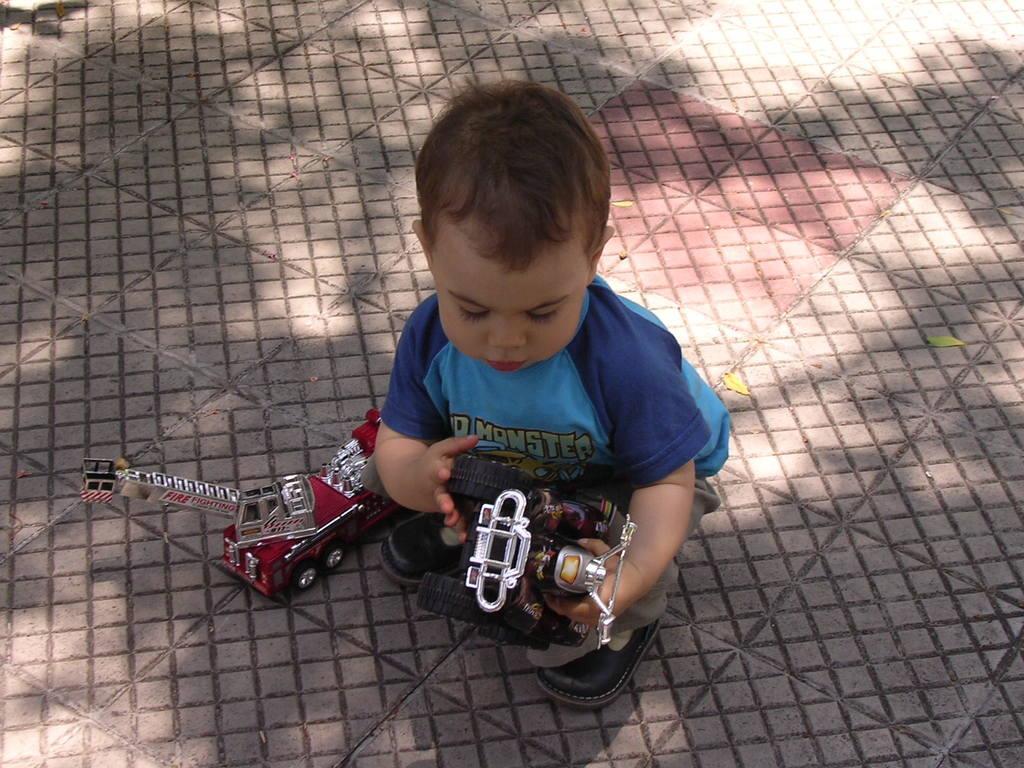How would you summarize this image in a sentence or two? Here I can see a baby wearing a blue color t-shirt, sitting on the floor and playing with the toys. 